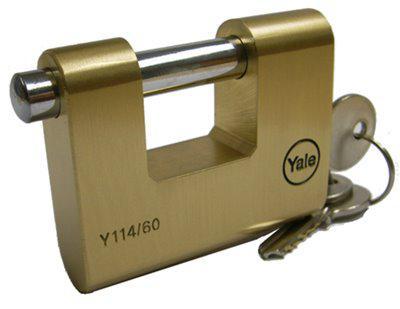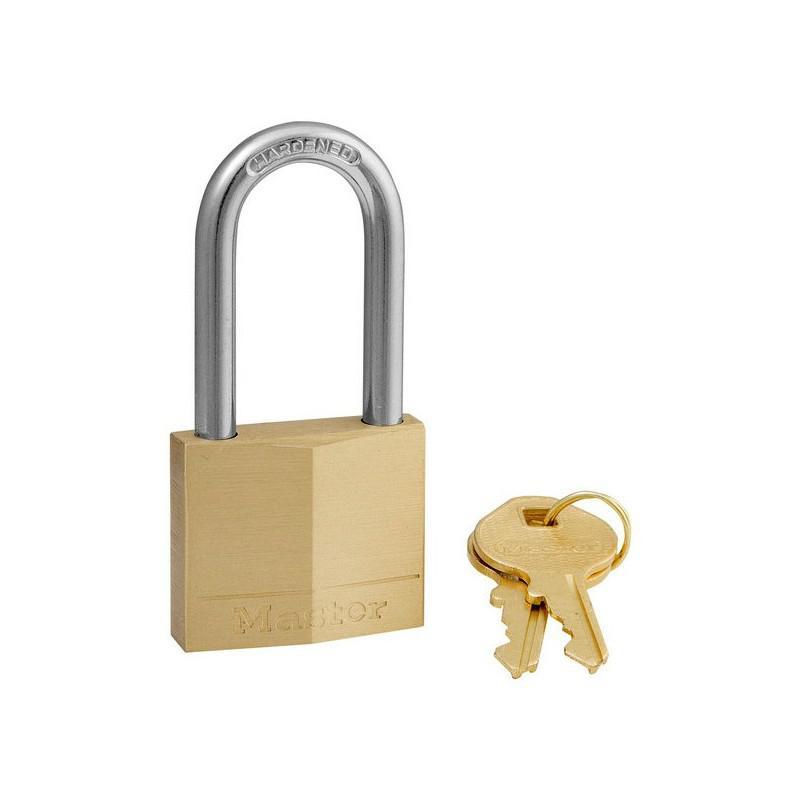The first image is the image on the left, the second image is the image on the right. Examine the images to the left and right. Is the description "An image includes a gold-colored lock with a loop taller than the body of the lock, and no keys present." accurate? Answer yes or no. No. The first image is the image on the left, the second image is the image on the right. Examine the images to the left and right. Is the description "The right image contains a lock with at least two keys." accurate? Answer yes or no. Yes. 